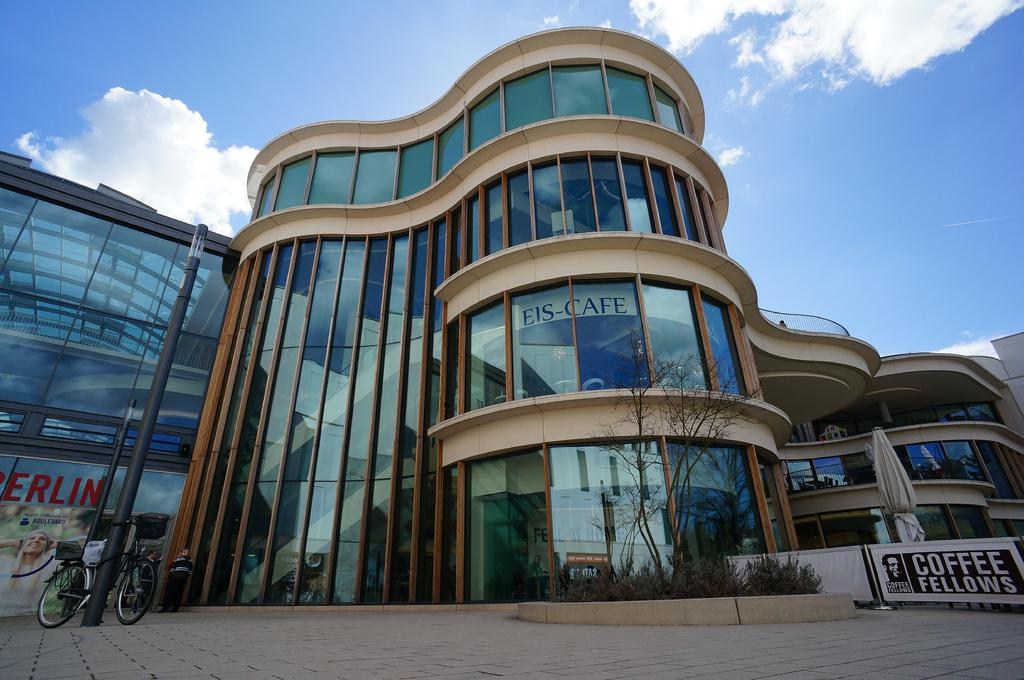What can be seen in the center of the image? The sky is visible in the center of the image. What is present in the sky? Clouds are present in the image. What type of structure can be seen in the image? There is at least one building in the image. What mode of transportation is present in the image? A cycle is present in the image. What type of vegetation is visible in the image? Plants are visible in the image. Who or what else is present in the image? There are people in the image. Can you describe any other objects in the image? There are other unspecified objects in the image. What type of vessel is being used to navigate the clouds in the image? There is no vessel present in the image, as it only features clouds in the sky. What type of cloud is depicted in the scene? The provided facts do not specify the type of clouds present in the image, only that clouds are visible. 